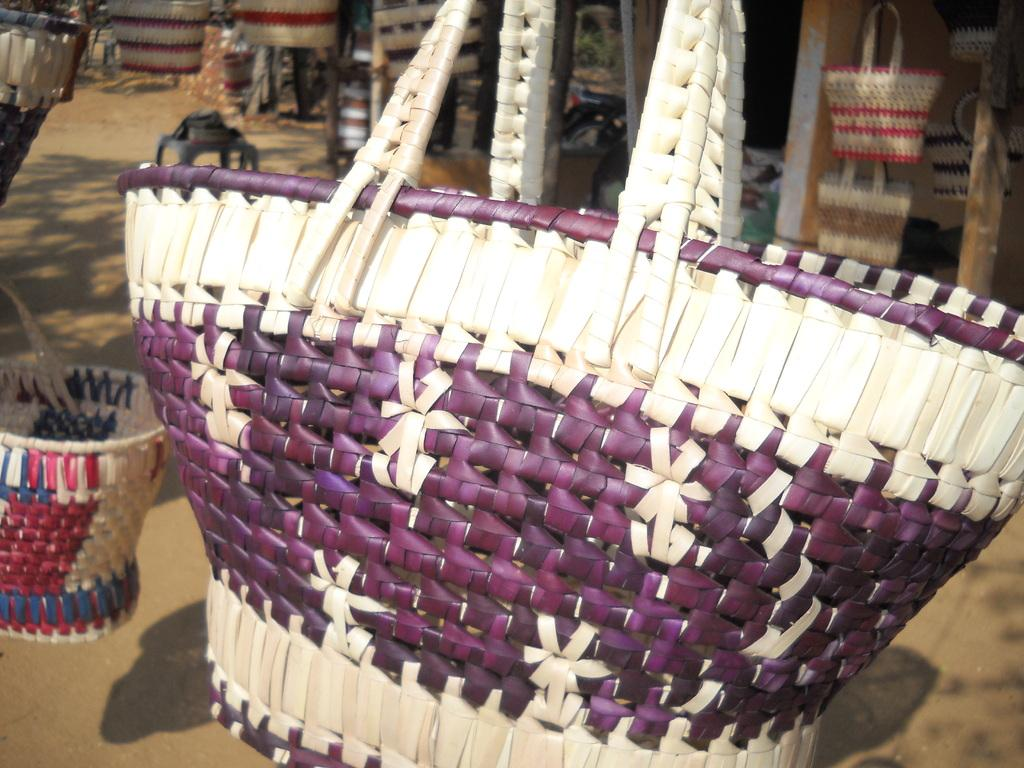What objects are present in the image? There are baskets in the image. Can you describe the baskets in the image? Unfortunately, the facts provided do not give any details about the baskets. Are the baskets empty or filled with something? The facts provided do not give any information about the contents of the baskets. What floor is the committee meeting taking place on in the image? There is no mention of a committee or a meeting in the image, and the facts provided do not give any information about the location or setting of the image. 